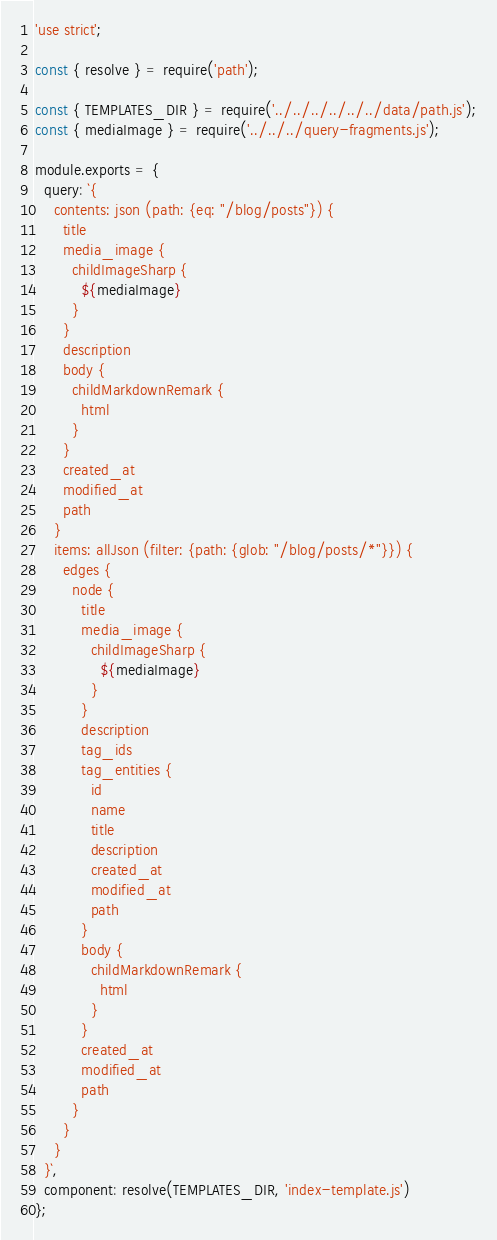<code> <loc_0><loc_0><loc_500><loc_500><_JavaScript_>'use strict';

const { resolve } = require('path');

const { TEMPLATES_DIR } = require('../../../../../../data/path.js');
const { mediaImage } = require('../../../query-fragments.js');

module.exports = {
  query: `{
    contents: json (path: {eq: "/blog/posts"}) {
      title
      media_image {
        childImageSharp {
          ${mediaImage}
        }
      }
      description
      body {
        childMarkdownRemark {
          html
        }
      }
      created_at
      modified_at
      path
    }
    items: allJson (filter: {path: {glob: "/blog/posts/*"}}) {
      edges {
        node {
          title
          media_image {
            childImageSharp {
              ${mediaImage}
            }
          }
          description
          tag_ids
          tag_entities {
            id
            name
            title
            description
            created_at
            modified_at
            path
          }
          body {
            childMarkdownRemark {
              html
            }
          }
          created_at
          modified_at
          path
        }
      }
    }
  }`,
  component: resolve(TEMPLATES_DIR, 'index-template.js')
};
</code> 